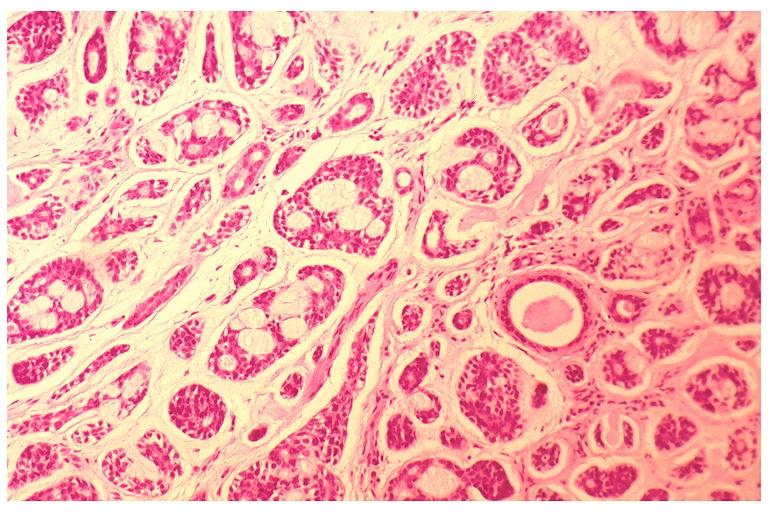where is this?
Answer the question using a single word or phrase. Oral 